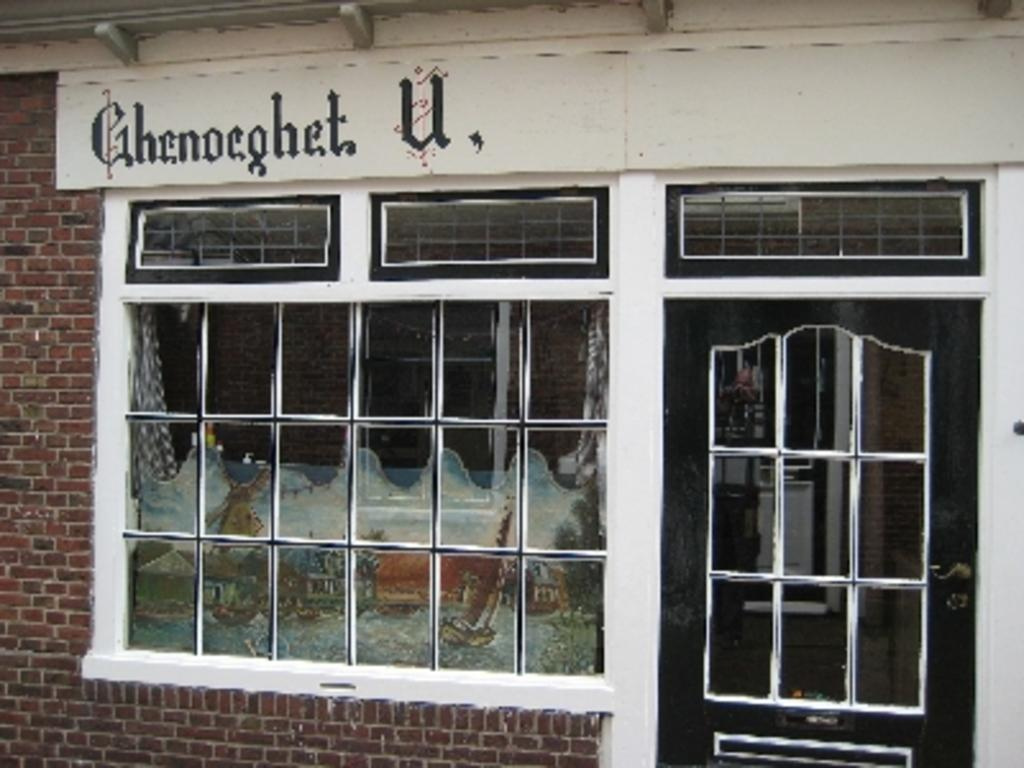<image>
Relay a brief, clear account of the picture shown. A store with the name Ghenoeghet U is in view. 